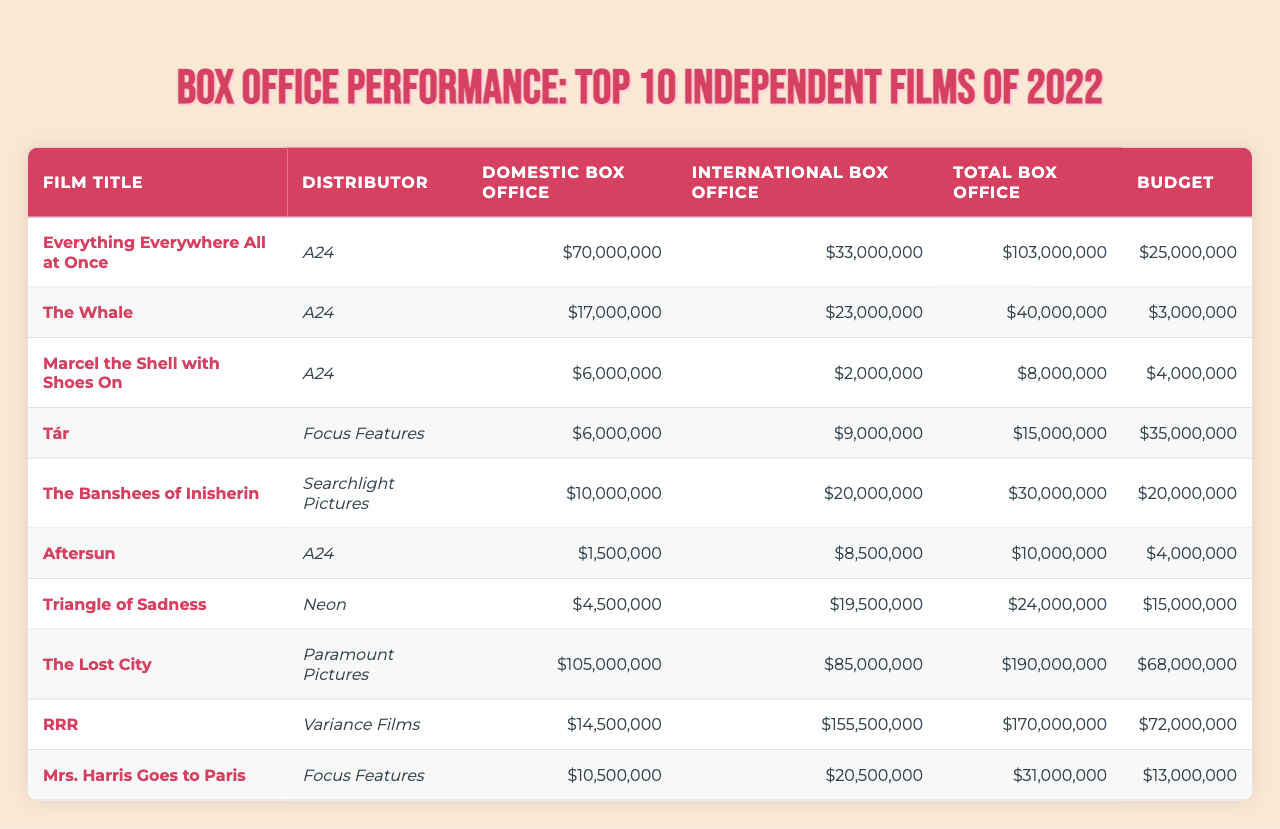What is the domestic box office for "The Whale"? The domestic box office for "The Whale" is listed directly in the table, which shows a value of $17,000,000.
Answer: 17,000,000 Which film had the highest total box office? By reviewing the total box office figures in the table, "The Lost City" has the highest value at $190,000,000.
Answer: The Lost City What is the budget for "Tár"? The budget for "Tár" can be found in the table, and it shows a value of $35,000,000.
Answer: 35,000,000 How much more did "RRR" earn internationally than "Aftersun"? The international box office earnings for "RRR" are $155,500,000 and for "Aftersun" are $8,500,000. The difference is $155,500,000 - $8,500,000 = $147,000,000.
Answer: 147,000,000 What is the total box office average of all films listed in the table? The total box office figures are: $103,000,000 + $40,000,000 + $8,000,000 + $15,000,000 + $30,000,000 + $10,000,000 + $24,000,000 + $190,000,000 + $170,000,000 + $31,000,000 = $1,171,000,000. Dividing this by the 10 films gives an average of $117,100,000.
Answer: 117,100,000 Did "Marcel the Shell with Shoes On" have a higher budget than "Aftersun"? The budget for "Marcel the Shell with Shoes On" is $4,000,000 and for "Aftersun" is also $4,000,000. Since they are the same, the answer is no.
Answer: No Which distributor had the highest total box office earnings? We need to compare the total box office earnings grouped by distributors. A24 had $103,000,000 + $40,000,000 + $8,000,000 + $10,000,000 = $161,000,000. Focus Features had $15,000,000 + $31,000,000 = $46,000,000. Searchlight Pictures had $30,000,000, Neon had $24,000,000, and Paramount Pictures had $190,000,000, and Variance Films had $170,000,000. The highest total goes to A24 with $161,000,000.
Answer: A24 What was the international box office total of all films combined? To find the total international box office, we sum up all international box office numbers: $33,000,000 + $23,000,000 + $2,000,000 + $9,000,000 + $20,000,000 + $8,500,000 + $19,500,000 + $85,000,000 + $155,500,000 + $20,500,000 = $355,000,000.
Answer: 355,000,000 Which film had the lowest domestic box office? Reviewing the domestic box office figures, "Aftersun" reports the lowest earnings at $1,500,000.
Answer: Aftersun What was the difference in total box office between "Everything Everywhere All at Once" and "The Banshees of Inisherin"? The total box office for "Everything Everywhere All at Once" is $103,000,000, and for "The Banshees of Inisherin," it is $30,000,000. The difference is $103,000,000 - $30,000,000 = $73,000,000.
Answer: 73,000,000 Do all films listed have a budget of over $1,000,000? By checking the budgets in the table, we see every film has a budget greater than $1,000,000, with the lowest being $3,000,000 for "The Whale." Therefore, the answer is yes.
Answer: Yes 